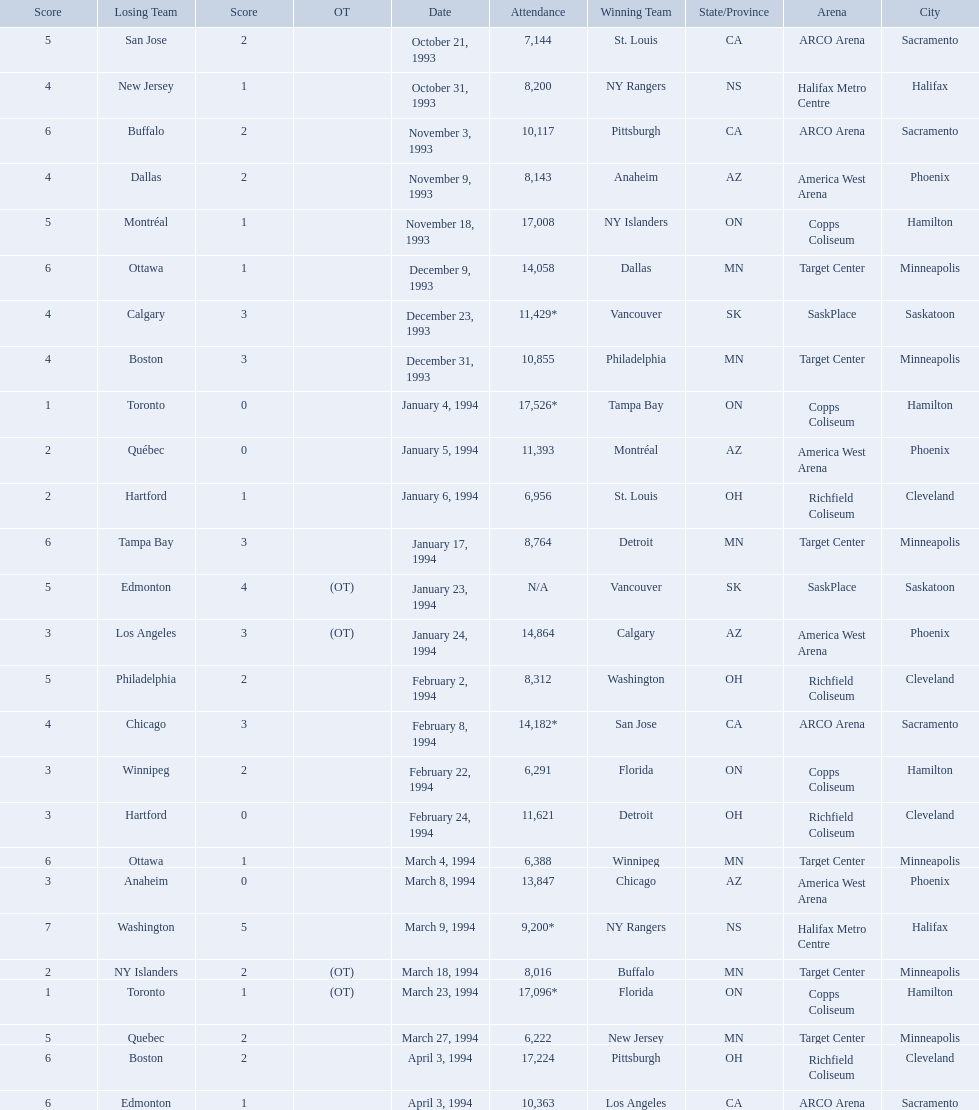When were the games played? October 21, 1993, October 31, 1993, November 3, 1993, November 9, 1993, November 18, 1993, December 9, 1993, December 23, 1993, December 31, 1993, January 4, 1994, January 5, 1994, January 6, 1994, January 17, 1994, January 23, 1994, January 24, 1994, February 2, 1994, February 8, 1994, February 22, 1994, February 24, 1994, March 4, 1994, March 8, 1994, March 9, 1994, March 18, 1994, March 23, 1994, March 27, 1994, April 3, 1994, April 3, 1994. What was the attendance for those games? 7,144, 8,200, 10,117, 8,143, 17,008, 14,058, 11,429*, 10,855, 17,526*, 11,393, 6,956, 8,764, N/A, 14,864, 8,312, 14,182*, 6,291, 11,621, 6,388, 13,847, 9,200*, 8,016, 17,096*, 6,222, 17,224, 10,363. Which date had the highest attendance? January 4, 1994. Which dates saw the winning team score only one point? January 4, 1994, March 23, 1994. Of these two, which date had higher attendance? January 4, 1994. 